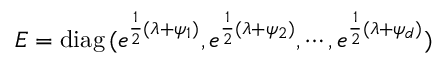<formula> <loc_0><loc_0><loc_500><loc_500>E = d i a g \, ( e ^ { { \frac { 1 } { 2 } } ( \lambda + \psi _ { 1 } ) } , e ^ { { \frac { 1 } { 2 } } ( \lambda + \psi _ { 2 } ) } , \cdots , e ^ { { \frac { 1 } { 2 } } ( \lambda + \psi _ { d } ) } )</formula> 